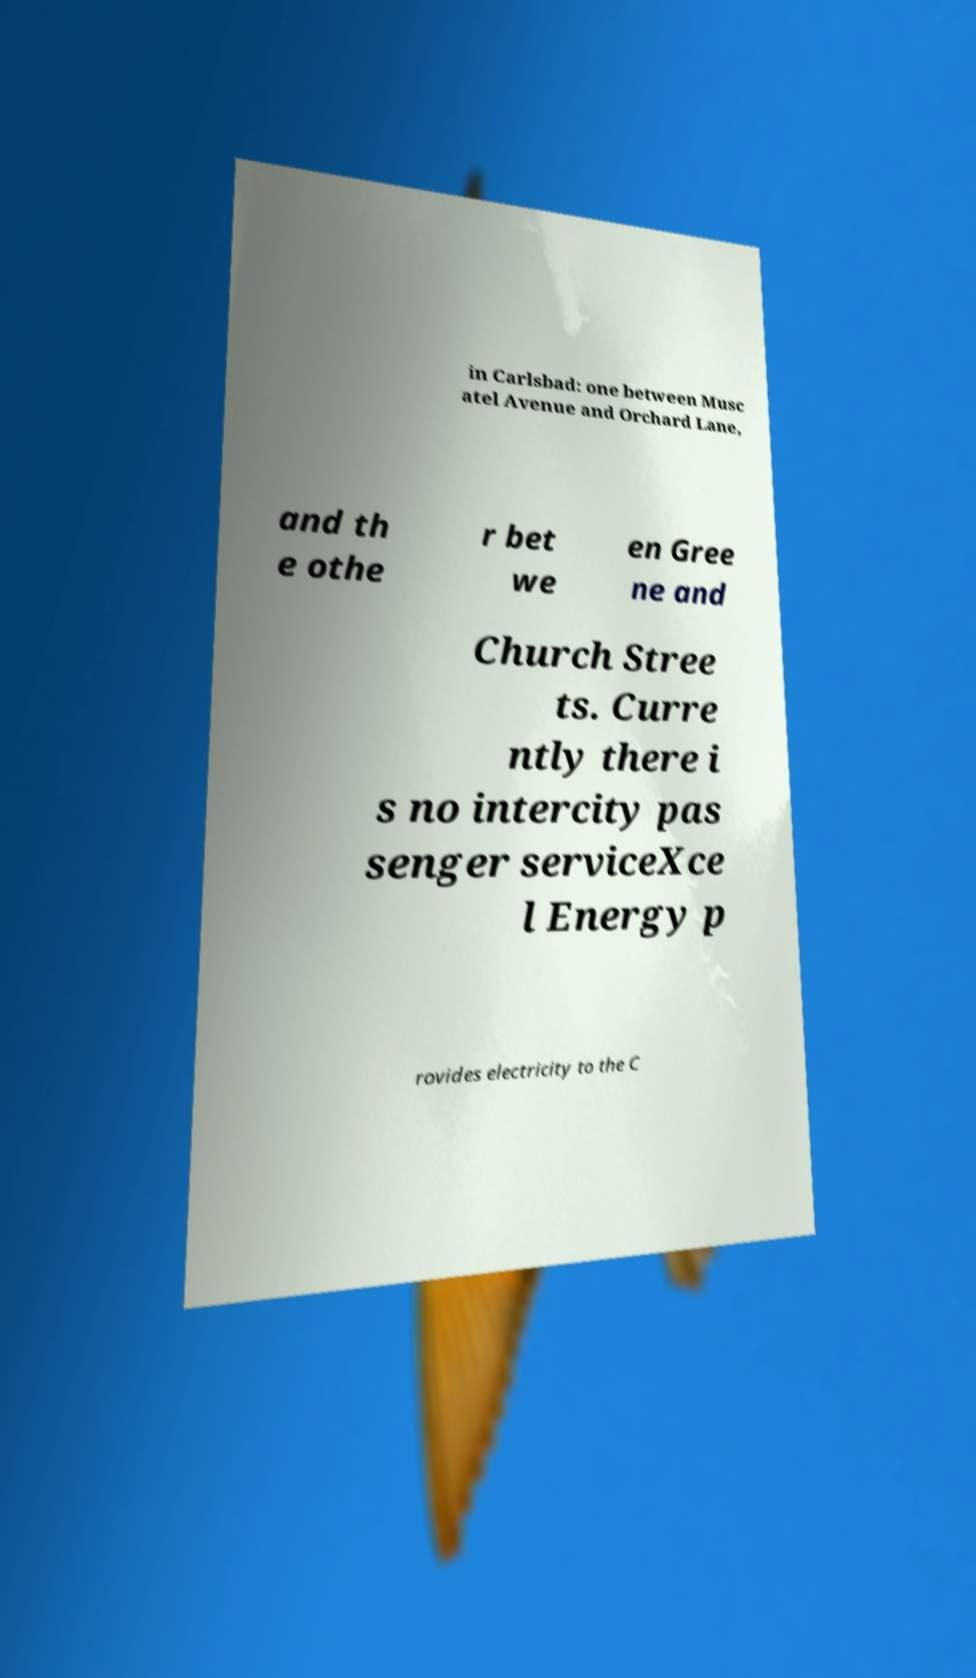Could you extract and type out the text from this image? in Carlsbad: one between Musc atel Avenue and Orchard Lane, and th e othe r bet we en Gree ne and Church Stree ts. Curre ntly there i s no intercity pas senger serviceXce l Energy p rovides electricity to the C 